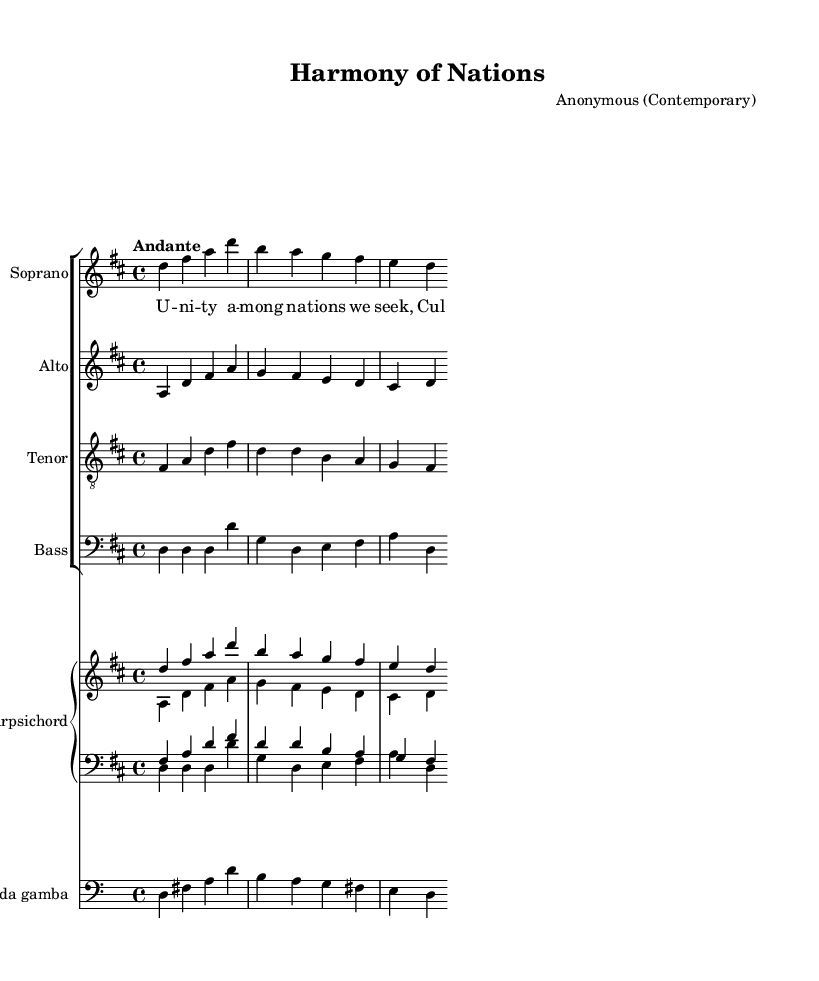What is the key signature of this music? The key signature is indicated at the beginning of the staff, showing two sharps (F# and C#), which means the piece is in D major.
Answer: D major What is the time signature of this music? The time signature is located at the beginning of the staff, and it shows a 4 over 4 indicating there are four beats in each measure.
Answer: 4/4 What is the tempo marking of this piece? The tempo marking is placed above the staff at the beginning of the music and indicates the speed at which the piece should be played, which is "Andante."
Answer: Andante How many vocal parts are included in this score? By counting the individual staves for each voice in the choir section, we find four: Soprano, Alto, Tenor, and Bass, thus totaling four parts.
Answer: Four Which historical musical period does this piece belong to? Given the structure, instrumentation, and style typical of the composition, it is evident that this piece derives from the Baroque period characterized by its ornate detail and vocal harmony.
Answer: Baroque What themes are explored in the lyrics of this choral work? The lyrics reflect concepts of unity among nations and cultural exchange, indicating a focus on collaboration and shared beliefs, aligning with the broader themes in the piece.
Answer: Unity and cultural exchange What additional instrument is included in this score besides the voices? The score includes a staff for the Harpsichord that provides accompaniment, along with a part for Viola da gamba, which is characteristic of the Baroque ensemble.
Answer: Harpsichord and Viola da gamba 